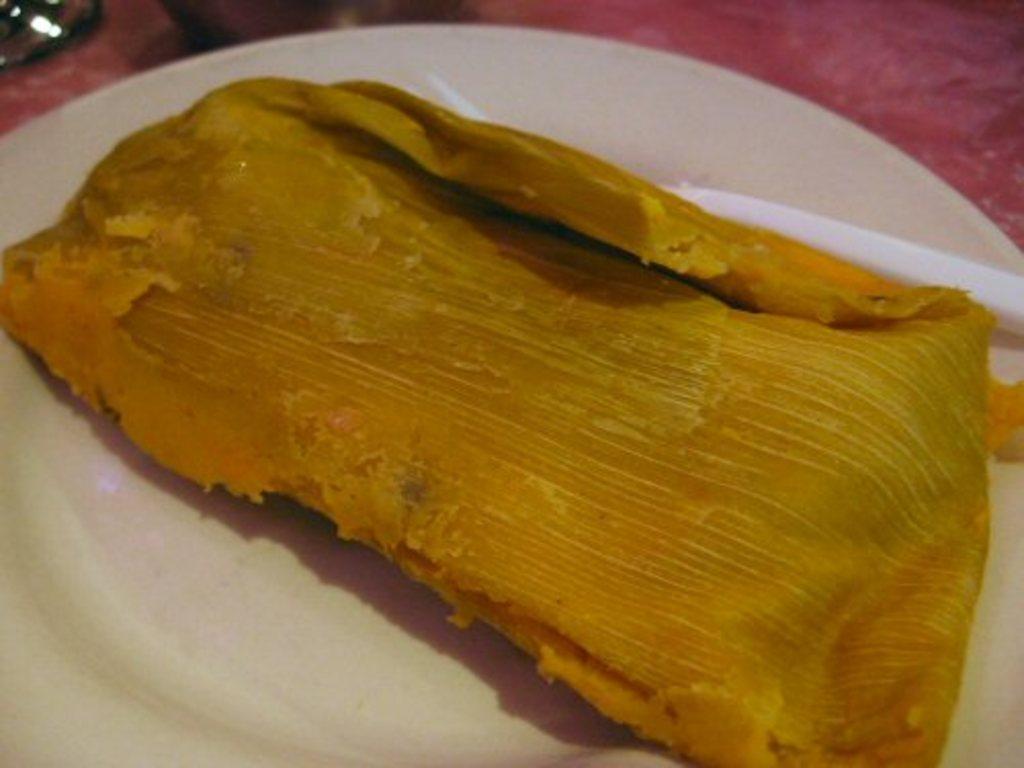How would you summarize this image in a sentence or two? In this image there is a table, on that table there is a plate, in that place there is a food item. 